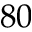Convert formula to latex. <formula><loc_0><loc_0><loc_500><loc_500>8 0</formula> 